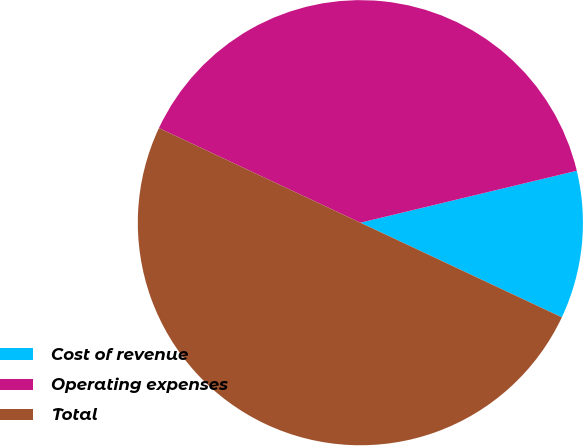<chart> <loc_0><loc_0><loc_500><loc_500><pie_chart><fcel>Cost of revenue<fcel>Operating expenses<fcel>Total<nl><fcel>10.74%<fcel>39.26%<fcel>50.0%<nl></chart> 